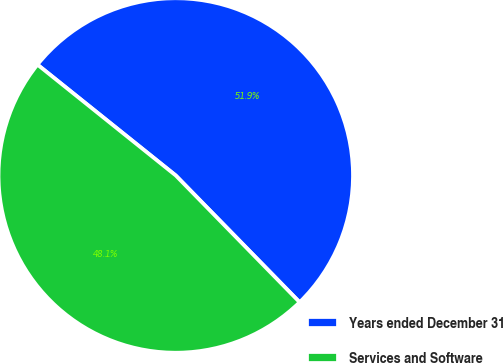<chart> <loc_0><loc_0><loc_500><loc_500><pie_chart><fcel>Years ended December 31<fcel>Services and Software<nl><fcel>51.93%<fcel>48.07%<nl></chart> 